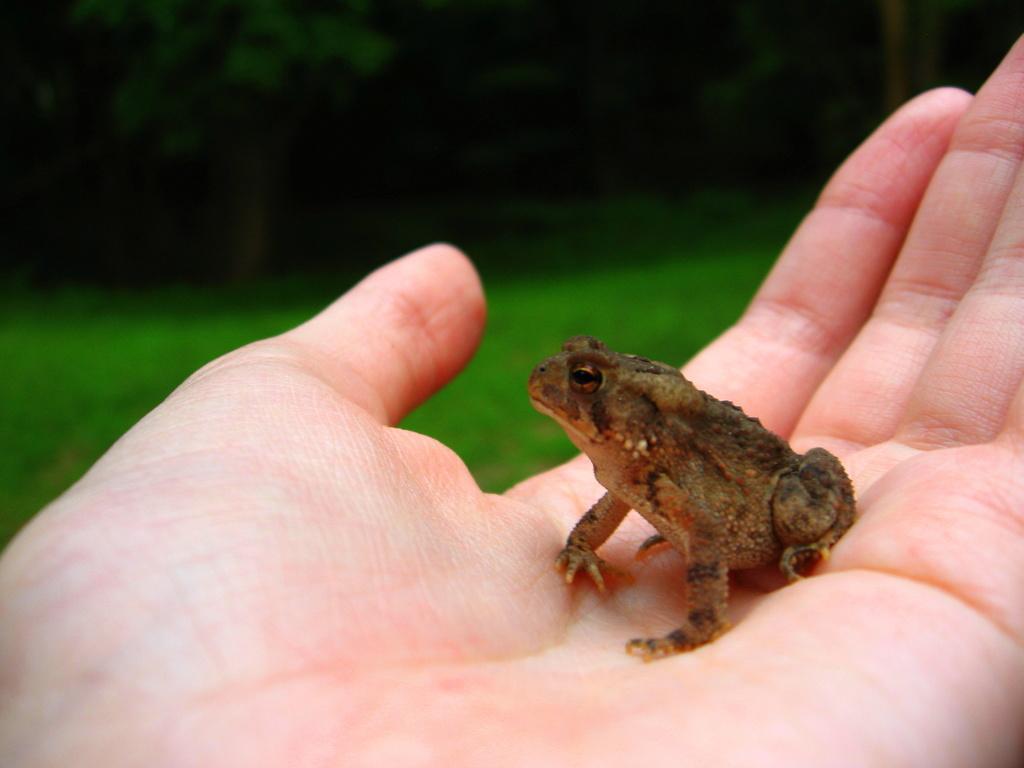Please provide a concise description of this image. In this image I can see a person's hand which is holding a frog. 